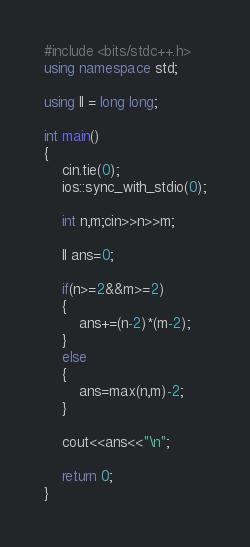Convert code to text. <code><loc_0><loc_0><loc_500><loc_500><_C++_>#include <bits/stdc++.h>
using namespace std;

using ll = long long;

int main()
{
    cin.tie(0);
    ios::sync_with_stdio(0);

    int n,m;cin>>n>>m;

    ll ans=0;

    if(n>=2&&m>=2)
    {
        ans+=(n-2)*(m-2);
    }
    else
    {
        ans=max(n,m)-2;
    }    

    cout<<ans<<"\n";

    return 0;
}
</code> 